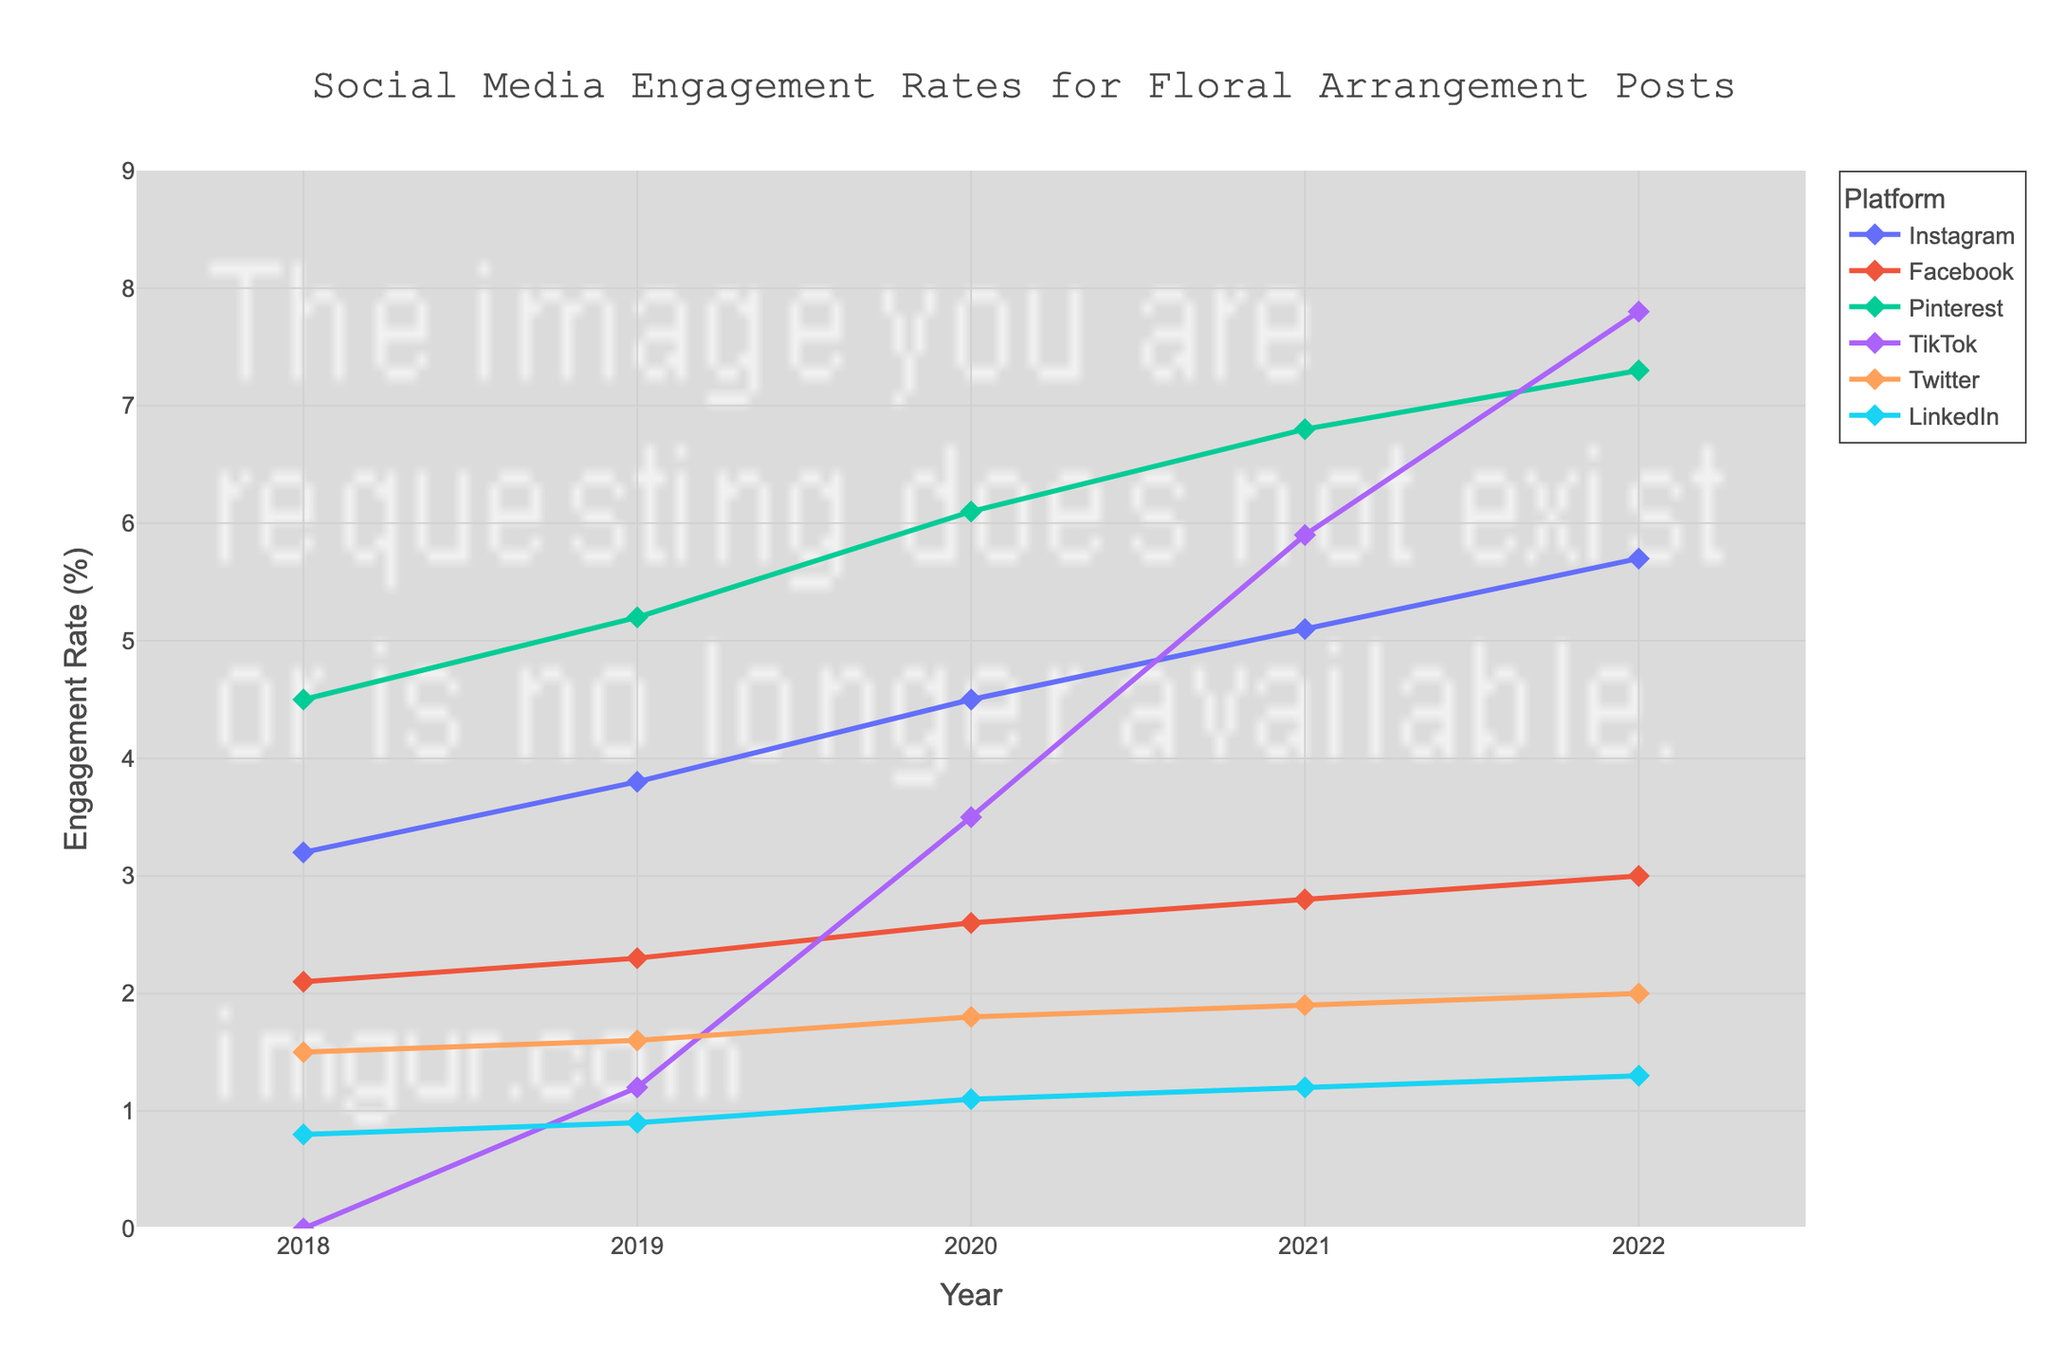What's the platform with the highest engagement rate in 2018? Look at the engagement rates for each platform in 2018 and identify the highest value. Pinterest has the highest engagement rate of 4.5% in 2018.
Answer: Pinterest Which platform showed the greatest increase in engagement rate from 2019 to 2022? Calculate the difference in engagement rates for each platform between 2019 and 2022. TikTok's increase is the highest: 7.8 - 1.2 = 6.6.
Answer: TikTok How did the engagement rate of Instagram in 2022 compare with LinkedIn's in 2020? Look at both the engagement rate of Instagram in 2022 (5.7%) and LinkedIn in 2020 (1.1%) and compare them. Instagram's is significantly higher.
Answer: Instagram is higher What is the average engagement rate across all platforms in 2020? Add up the engagement rates of all platforms in 2020 (4.5 + 2.6 + 6.1 + 3.5 + 1.8 + 1.1) and divide by the number of platforms, which is 6. The average is (4.5 + 2.6 + 6.1 + 3.5 + 1.8 + 1.1) / 6 = 3.27.
Answer: 3.27 Compare the trend of engagement rates between Instagram and TikTok from 2018 to 2022. Which platform had a faster growth rate? Look at the plotted lines for Instagram and TikTok from 2018 to 2022 and note their slopes. TikTok grew from 0 to 7.8, while Instagram grew from 3.2 to 5.7. The increase for TikTok is larger and faster.
Answer: TikTok Which year did Pinterest see the highest increase in engagement rate? Look at the year-to-year differences in engagement rates for Pinterest. The highest increase is from 2020 to 2021, where the rate increased from 6.1 to 6.8, i.e., 0.7.
Answer: 2021 What was the engagement rate of Facebook in 2019 and how does it compare to Twitter in the same year? Look at the engagement rates for both platforms in 2019: Facebook (2.3%) and Twitter (1.6%). Facebook's rate is higher.
Answer: Facebook is higher Compare the engagement rates of LinkedIn in 2018 and 2022. Did it increase or decrease, and by how much? Subtract the engagement rate of LinkedIn in 2018 (0.8) from its rate in 2022 (1.3). The engagement rate increased by 0.5.
Answer: Increased by 0.5 Is there any platform that consistently showed an increase in engagement rates every year from 2018 to 2022? Check each platform's engagement rate trend from 2018 to 2022. All platforms except Twitter and LinkedIn show a consistent increase. Pinterest and Instagram show the most consistent increases.
Answer: Pinterest and Instagram 